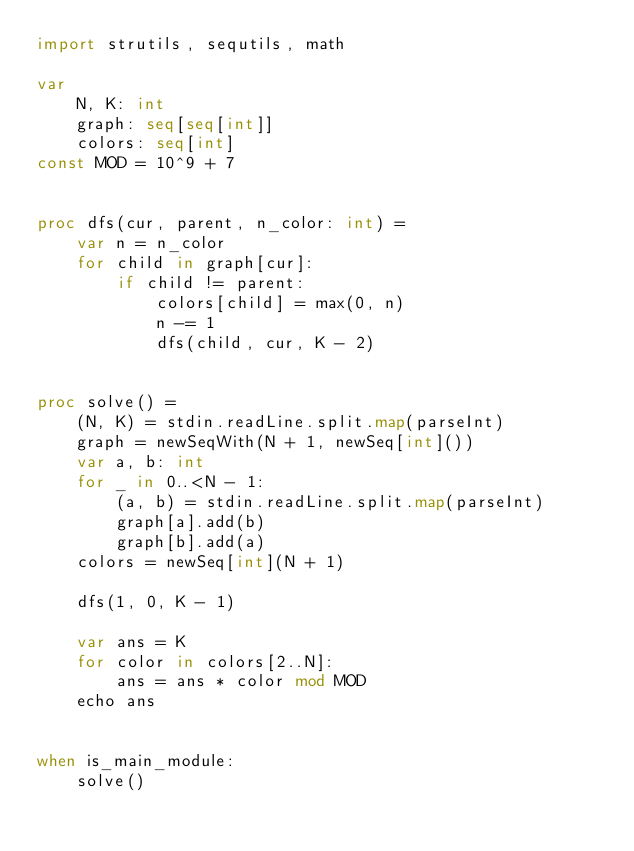Convert code to text. <code><loc_0><loc_0><loc_500><loc_500><_Nim_>import strutils, sequtils, math

var
    N, K: int
    graph: seq[seq[int]]
    colors: seq[int]
const MOD = 10^9 + 7


proc dfs(cur, parent, n_color: int) =
    var n = n_color
    for child in graph[cur]:
        if child != parent:
            colors[child] = max(0, n)
            n -= 1
            dfs(child, cur, K - 2)


proc solve() =
    (N, K) = stdin.readLine.split.map(parseInt)
    graph = newSeqWith(N + 1, newSeq[int]())
    var a, b: int
    for _ in 0..<N - 1:
        (a, b) = stdin.readLine.split.map(parseInt)
        graph[a].add(b)
        graph[b].add(a)
    colors = newSeq[int](N + 1)
    
    dfs(1, 0, K - 1)
    
    var ans = K
    for color in colors[2..N]:
        ans = ans * color mod MOD
    echo ans


when is_main_module:
    solve()
</code> 